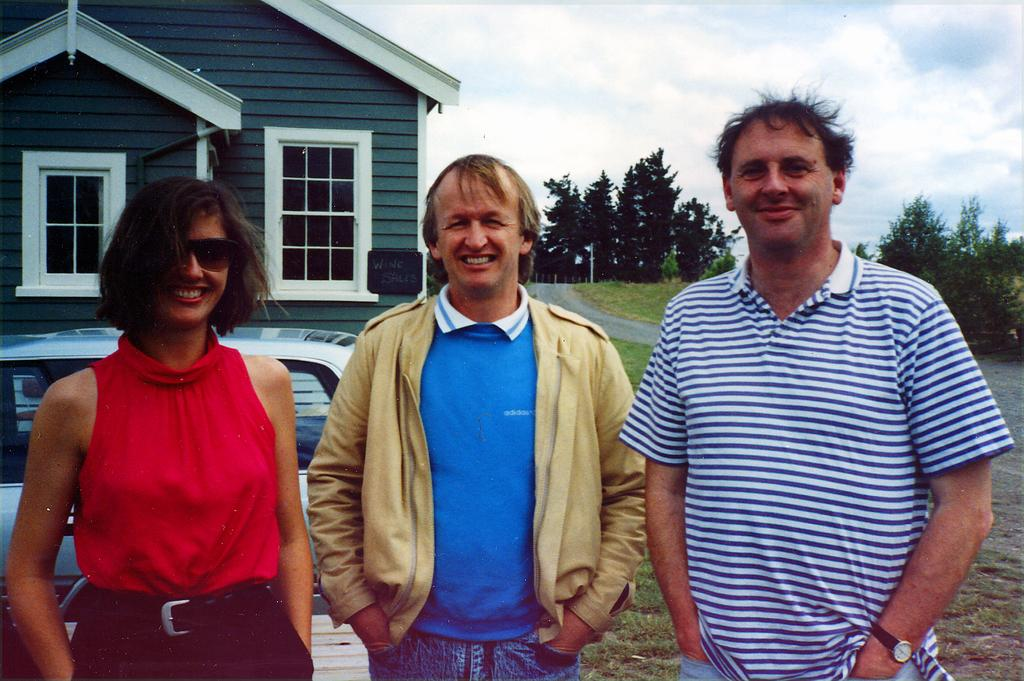How many people are in the image? There are three people in the image: one woman and two men. What is the facial expression of the people in the image? The people in the image are smiling. What can be seen in the background of the image? In the background of the image, there is a vehicle, a house, grass, a road, a pole, plants, trees, and the sky with clouds. What type of butter is being used in the story depicted in the image? There is no story or butter present in the image; it features three people smiling with various background elements. 